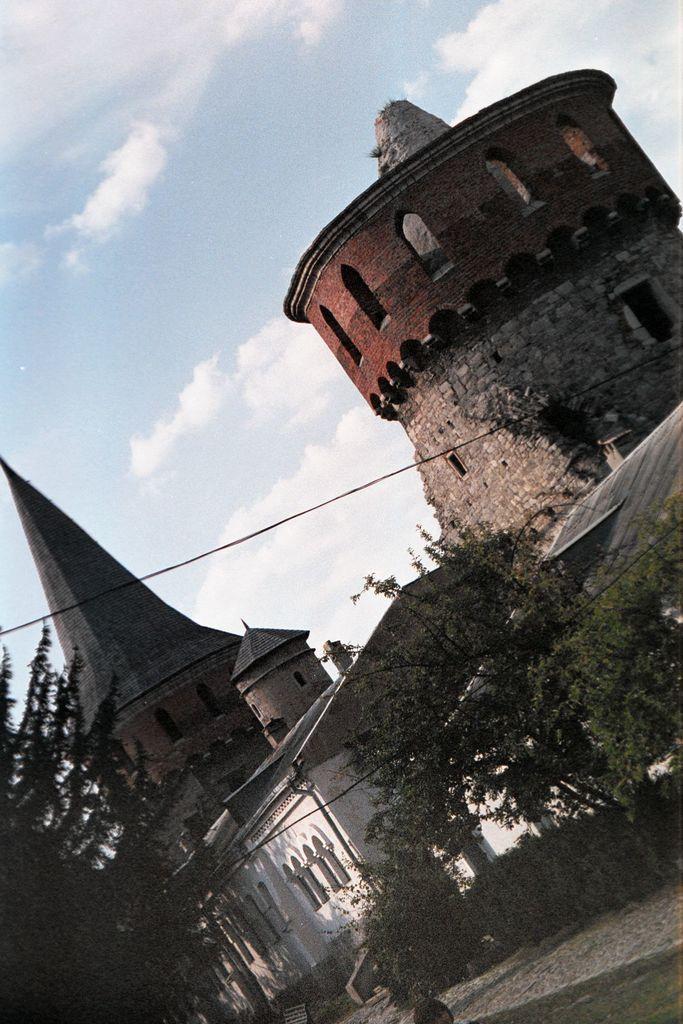Could you give a brief overview of what you see in this image? As we can see in the image there are buildings, trees, grass and on the top there is sky. 